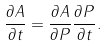<formula> <loc_0><loc_0><loc_500><loc_500>\frac { \partial A } { \partial t } = \frac { \partial A } { \partial P } \frac { \partial P } { \partial t } .</formula> 